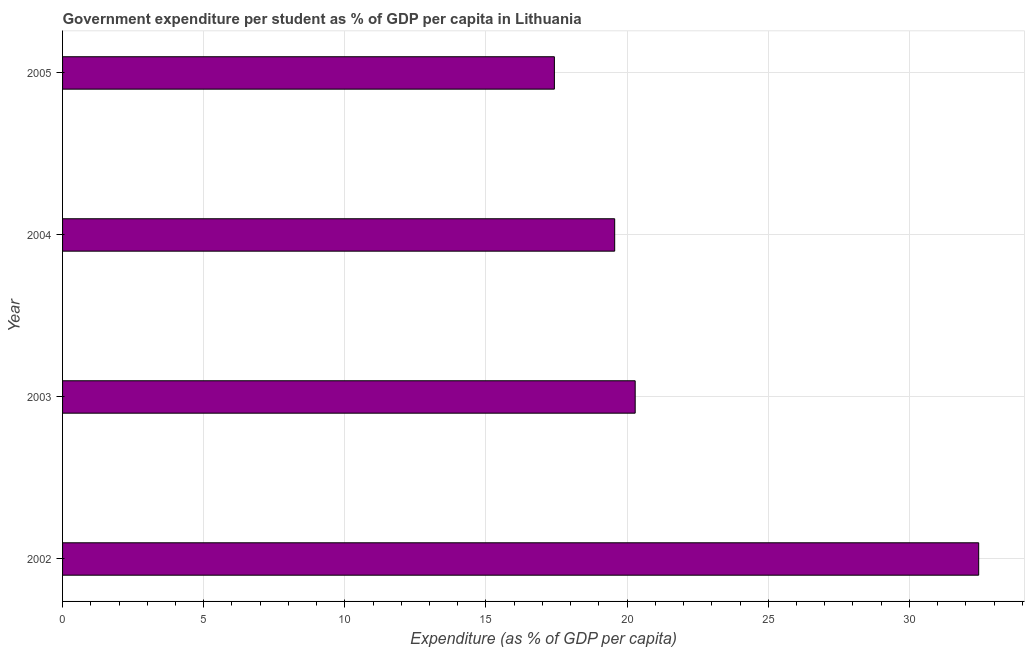Does the graph contain grids?
Keep it short and to the point. Yes. What is the title of the graph?
Make the answer very short. Government expenditure per student as % of GDP per capita in Lithuania. What is the label or title of the X-axis?
Make the answer very short. Expenditure (as % of GDP per capita). What is the government expenditure per student in 2003?
Ensure brevity in your answer.  20.29. Across all years, what is the maximum government expenditure per student?
Give a very brief answer. 32.45. Across all years, what is the minimum government expenditure per student?
Your answer should be very brief. 17.42. In which year was the government expenditure per student minimum?
Ensure brevity in your answer.  2005. What is the sum of the government expenditure per student?
Your response must be concise. 89.72. What is the difference between the government expenditure per student in 2004 and 2005?
Offer a very short reply. 2.14. What is the average government expenditure per student per year?
Give a very brief answer. 22.43. What is the median government expenditure per student?
Keep it short and to the point. 19.92. In how many years, is the government expenditure per student greater than 16 %?
Your answer should be very brief. 4. What is the ratio of the government expenditure per student in 2002 to that in 2005?
Your answer should be compact. 1.86. Is the government expenditure per student in 2003 less than that in 2005?
Your answer should be compact. No. Is the difference between the government expenditure per student in 2002 and 2005 greater than the difference between any two years?
Your answer should be very brief. Yes. What is the difference between the highest and the second highest government expenditure per student?
Provide a succinct answer. 12.17. What is the difference between the highest and the lowest government expenditure per student?
Make the answer very short. 15.03. What is the Expenditure (as % of GDP per capita) of 2002?
Provide a short and direct response. 32.45. What is the Expenditure (as % of GDP per capita) of 2003?
Your answer should be very brief. 20.29. What is the Expenditure (as % of GDP per capita) in 2004?
Keep it short and to the point. 19.56. What is the Expenditure (as % of GDP per capita) of 2005?
Your answer should be compact. 17.42. What is the difference between the Expenditure (as % of GDP per capita) in 2002 and 2003?
Ensure brevity in your answer.  12.17. What is the difference between the Expenditure (as % of GDP per capita) in 2002 and 2004?
Ensure brevity in your answer.  12.89. What is the difference between the Expenditure (as % of GDP per capita) in 2002 and 2005?
Your answer should be compact. 15.03. What is the difference between the Expenditure (as % of GDP per capita) in 2003 and 2004?
Your answer should be compact. 0.73. What is the difference between the Expenditure (as % of GDP per capita) in 2003 and 2005?
Ensure brevity in your answer.  2.86. What is the difference between the Expenditure (as % of GDP per capita) in 2004 and 2005?
Offer a terse response. 2.14. What is the ratio of the Expenditure (as % of GDP per capita) in 2002 to that in 2004?
Your answer should be very brief. 1.66. What is the ratio of the Expenditure (as % of GDP per capita) in 2002 to that in 2005?
Your answer should be compact. 1.86. What is the ratio of the Expenditure (as % of GDP per capita) in 2003 to that in 2004?
Offer a terse response. 1.04. What is the ratio of the Expenditure (as % of GDP per capita) in 2003 to that in 2005?
Offer a very short reply. 1.16. What is the ratio of the Expenditure (as % of GDP per capita) in 2004 to that in 2005?
Provide a short and direct response. 1.12. 